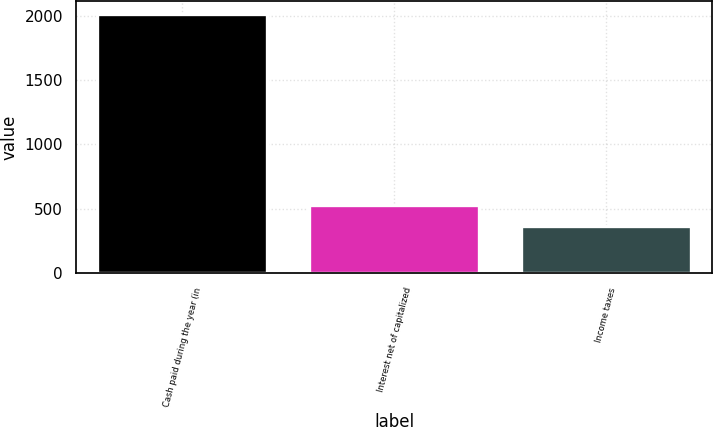Convert chart to OTSL. <chart><loc_0><loc_0><loc_500><loc_500><bar_chart><fcel>Cash paid during the year (in<fcel>Interest net of capitalized<fcel>Income taxes<nl><fcel>2012<fcel>530.6<fcel>366<nl></chart> 